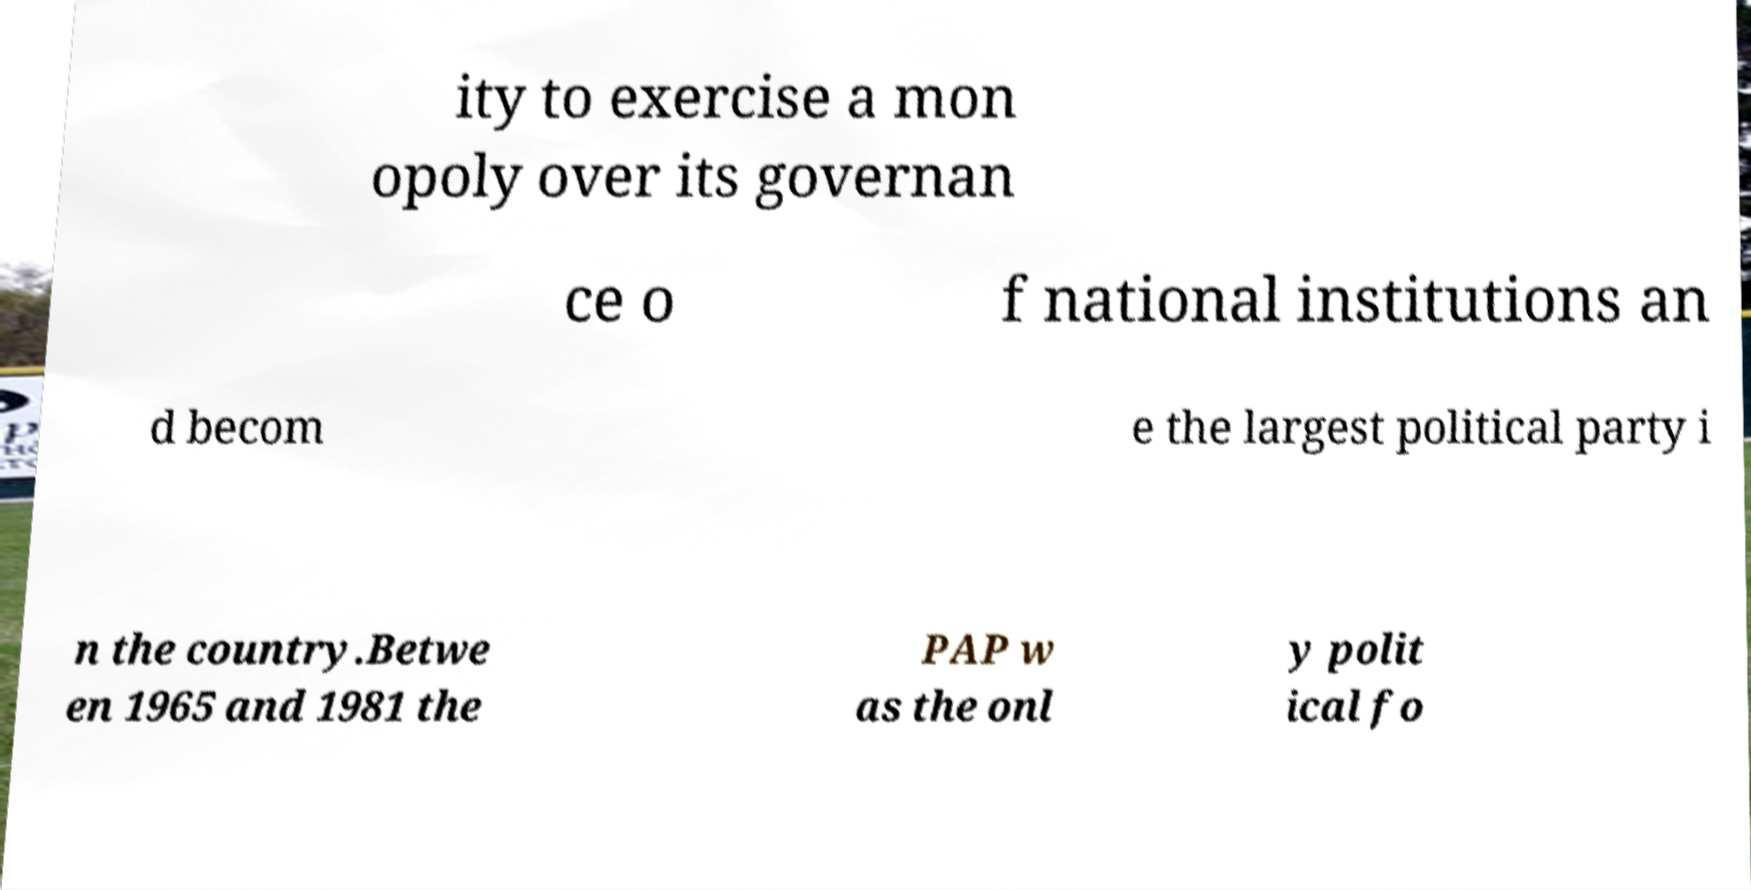Please identify and transcribe the text found in this image. ity to exercise a mon opoly over its governan ce o f national institutions an d becom e the largest political party i n the country.Betwe en 1965 and 1981 the PAP w as the onl y polit ical fo 